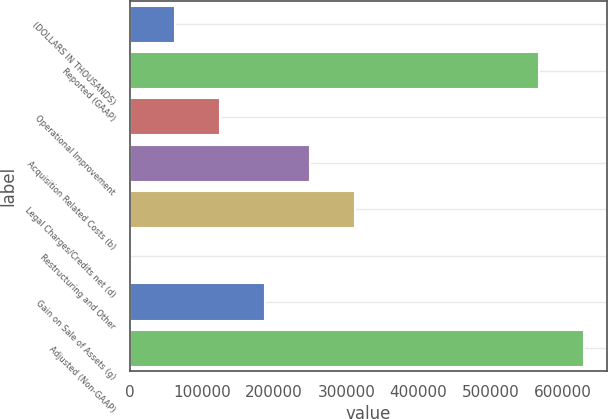<chart> <loc_0><loc_0><loc_500><loc_500><bar_chart><fcel>(DOLLARS IN THOUSANDS)<fcel>Reported (GAAP)<fcel>Operational Improvement<fcel>Acquisition Related Costs (b)<fcel>Legal Charges/Credits net (d)<fcel>Restructuring and Other<fcel>Gain on Sale of Assets (g)<fcel>Adjusted (Non-GAAP)<nl><fcel>62587.3<fcel>567356<fcel>124853<fcel>249383<fcel>311648<fcel>322<fcel>187118<fcel>629621<nl></chart> 